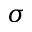<formula> <loc_0><loc_0><loc_500><loc_500>\sigma</formula> 